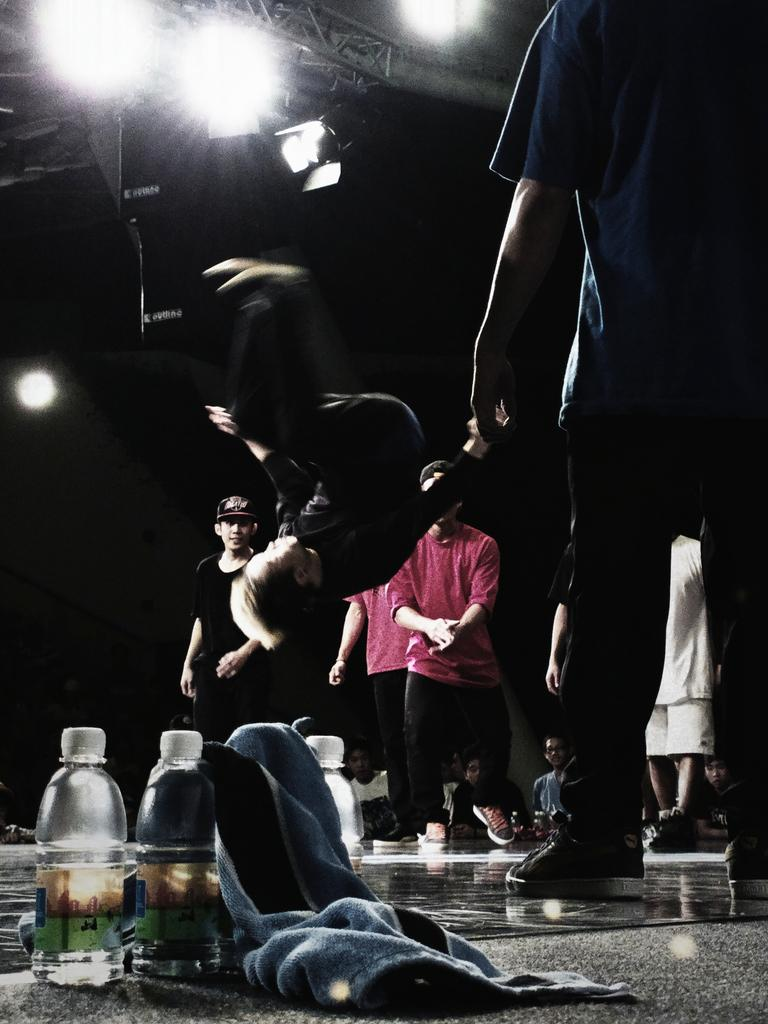What objects can be found at the bottom of the image? There are two bottles and a cloth in the bottom of the image. What is happening on the stage in the people are standing on? There are many people standing on a stage in the image. What is the man in the image doing? One man is rotating in the image. What can be seen at the top of the image? There are two lights in the top of the image. What statement is being made by the sheet in the image? There is no sheet present in the image, so no statement can be made by it. 